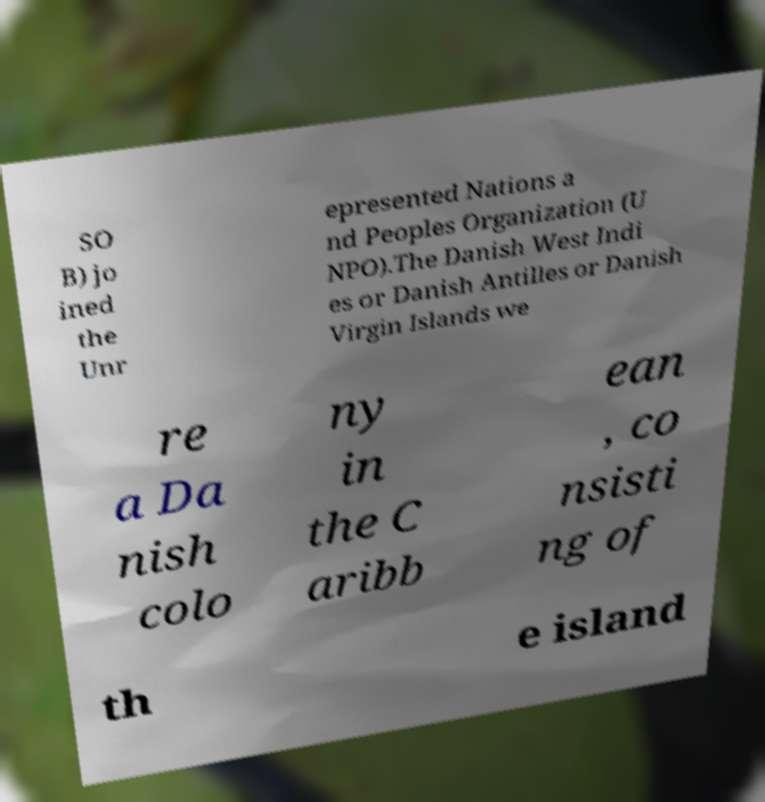For documentation purposes, I need the text within this image transcribed. Could you provide that? SO B) jo ined the Unr epresented Nations a nd Peoples Organization (U NPO).The Danish West Indi es or Danish Antilles or Danish Virgin Islands we re a Da nish colo ny in the C aribb ean , co nsisti ng of th e island 